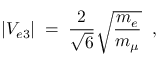Convert formula to latex. <formula><loc_0><loc_0><loc_500><loc_500>| V _ { e 3 } | \, = \, \frac { 2 } { \sqrt { 6 } } \sqrt { \frac { m _ { e } } { m _ { \mu } } } \, ,</formula> 